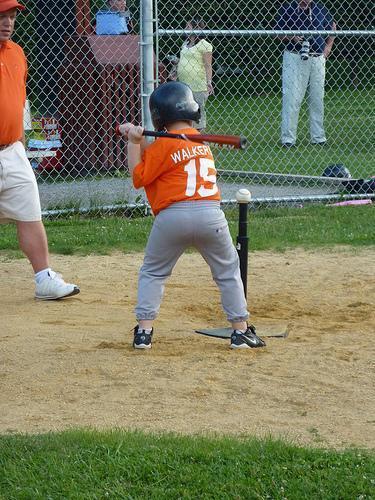How many players?
Give a very brief answer. 1. 